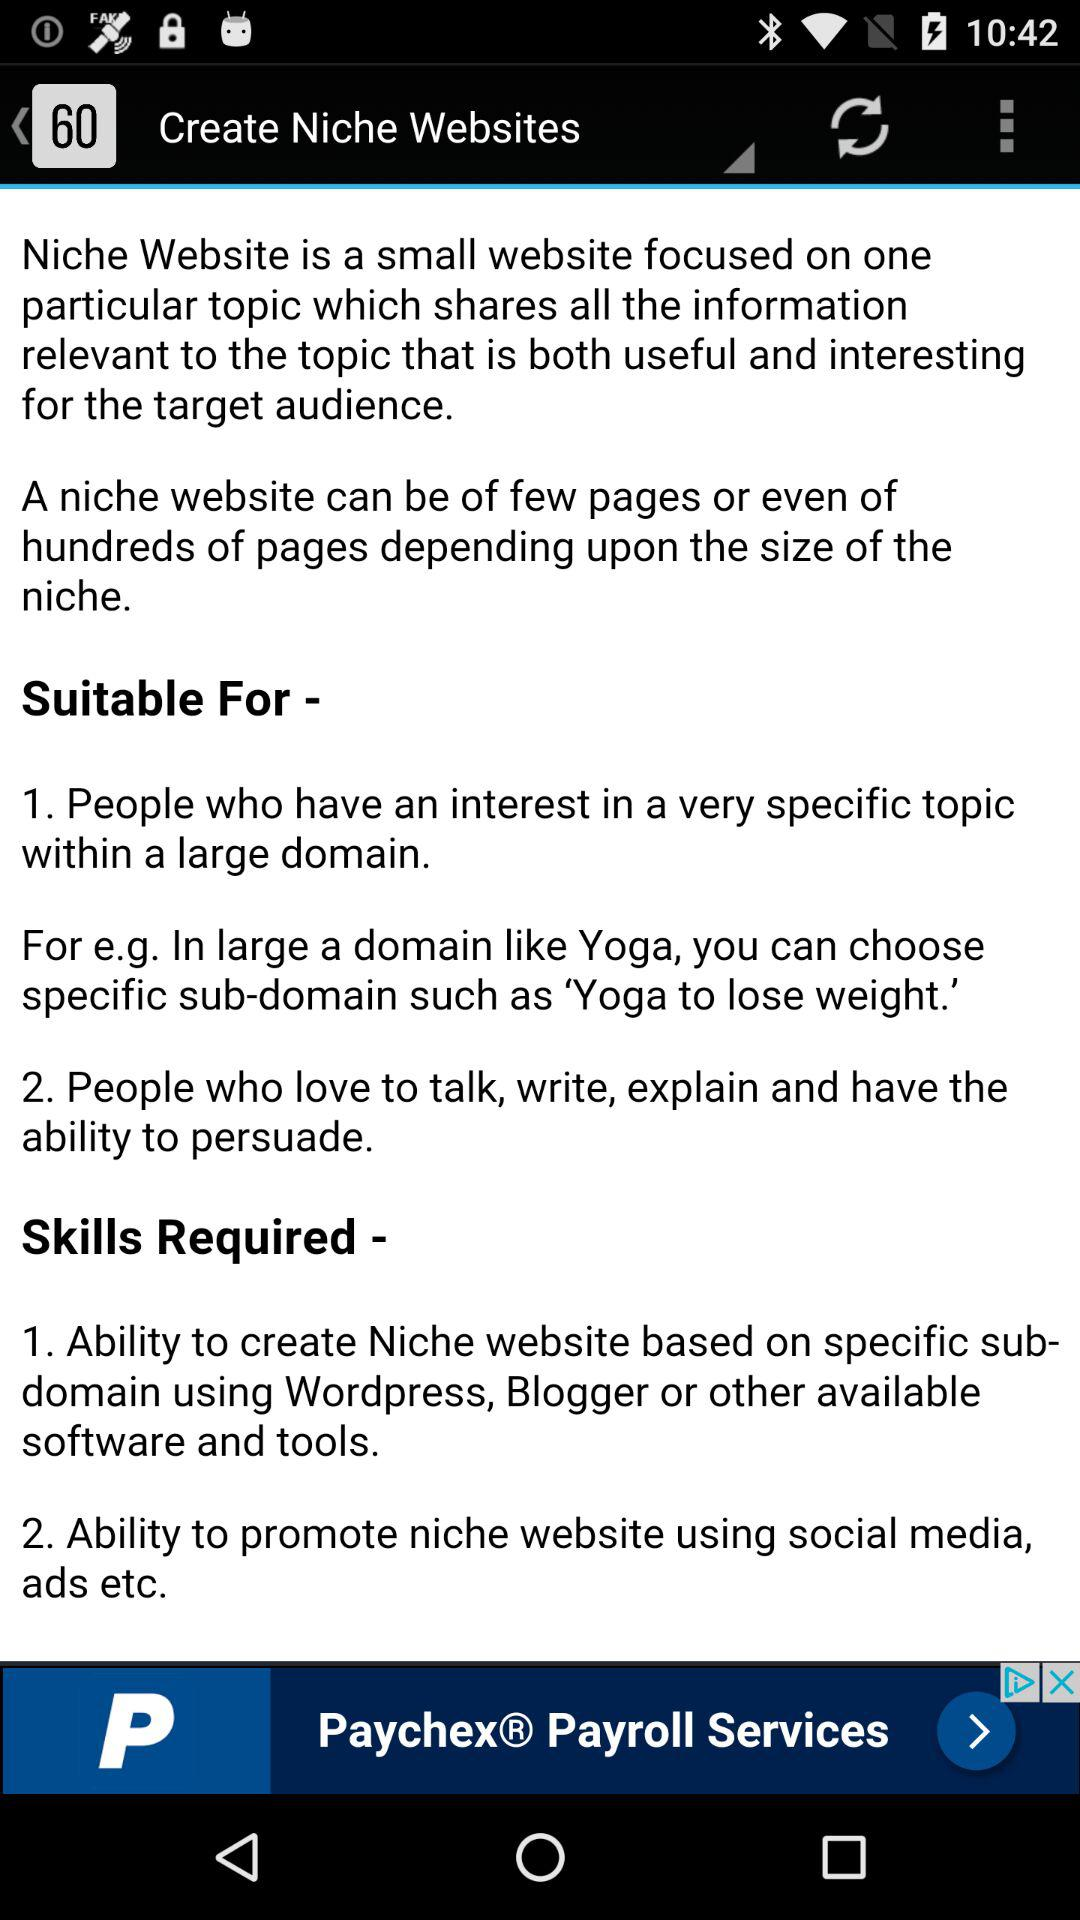How many skills are required to create a niche website?
Answer the question using a single word or phrase. 2 